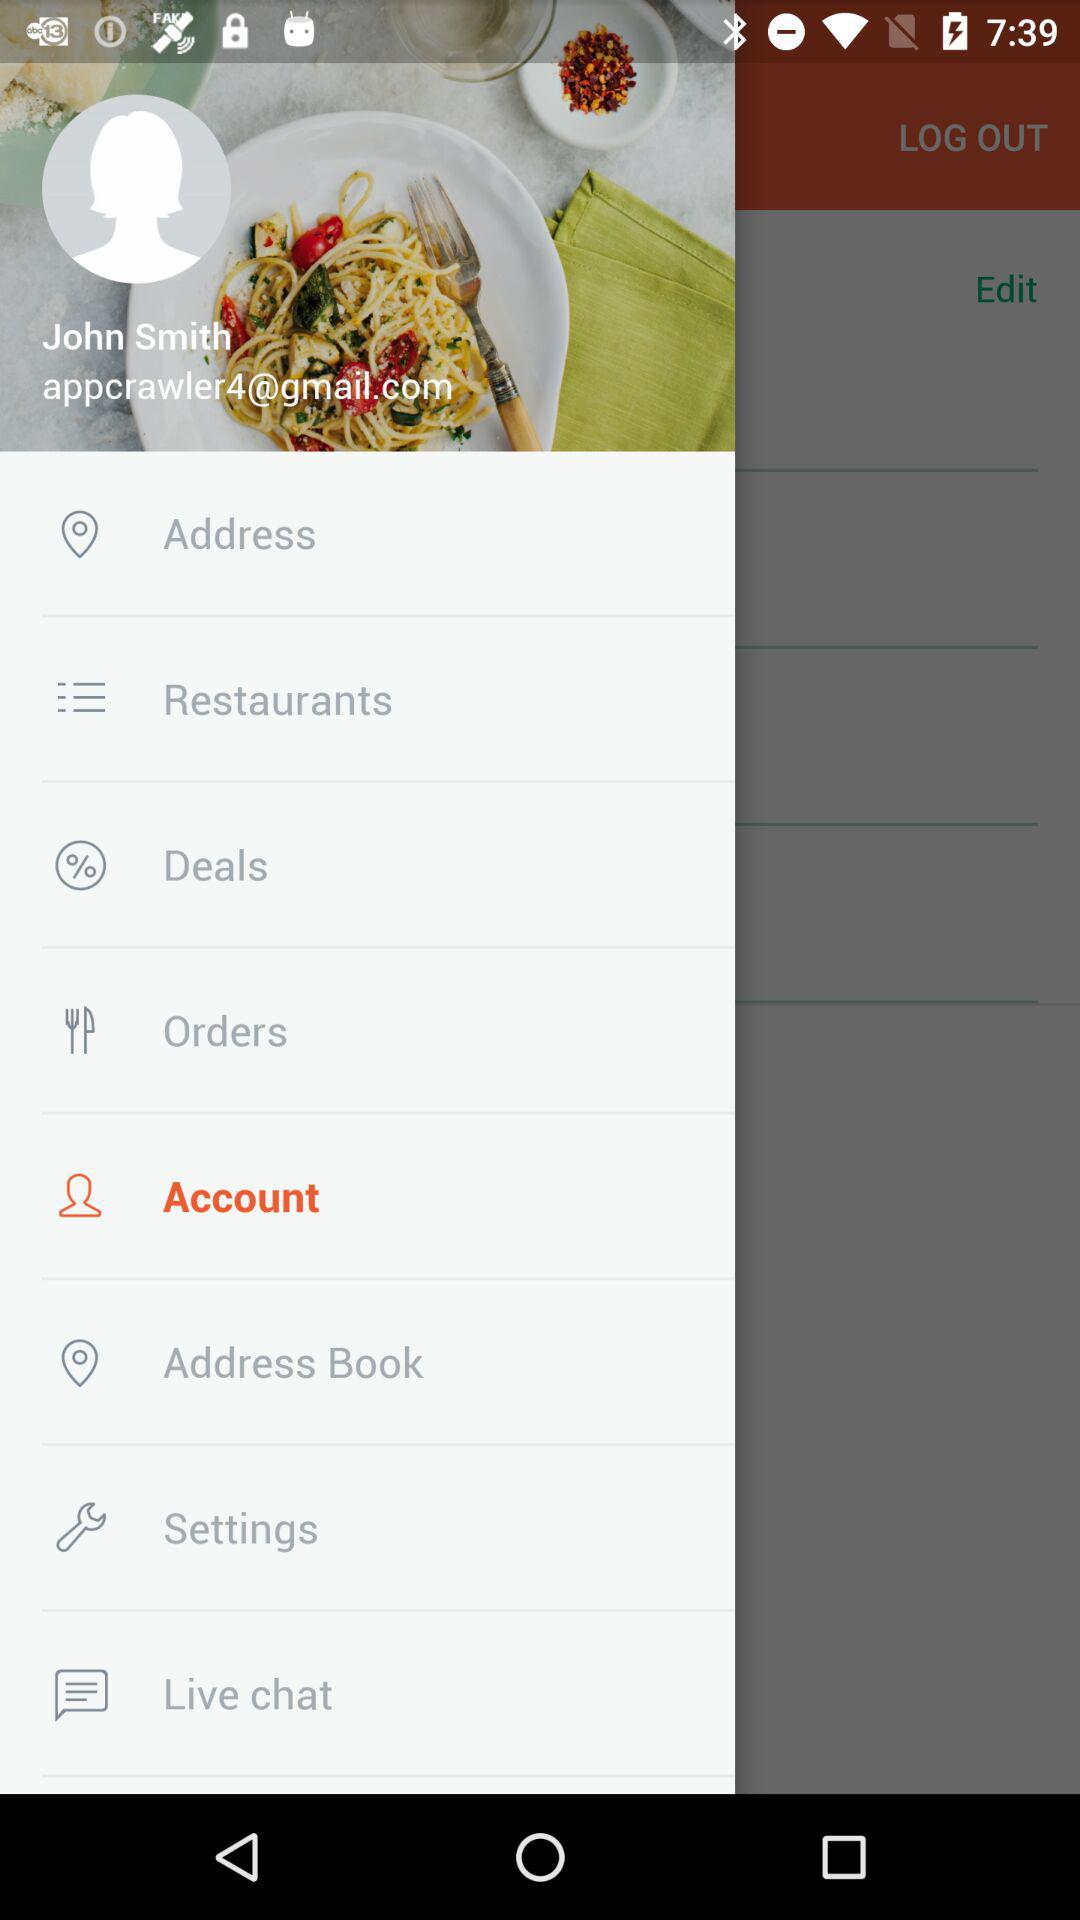What is the e-mail address? The e-mail address is appcrawler4@gmail.com. 